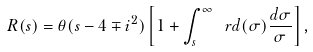Convert formula to latex. <formula><loc_0><loc_0><loc_500><loc_500>R ( s ) = \theta ( s - 4 \mp i ^ { 2 } ) \left [ 1 + \int _ { s } ^ { \infty } \ r d ( \sigma ) \frac { d \sigma } { \sigma } \right ] ,</formula> 